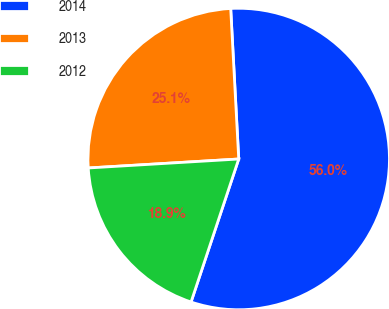Convert chart to OTSL. <chart><loc_0><loc_0><loc_500><loc_500><pie_chart><fcel>2014<fcel>2013<fcel>2012<nl><fcel>55.97%<fcel>25.1%<fcel>18.93%<nl></chart> 